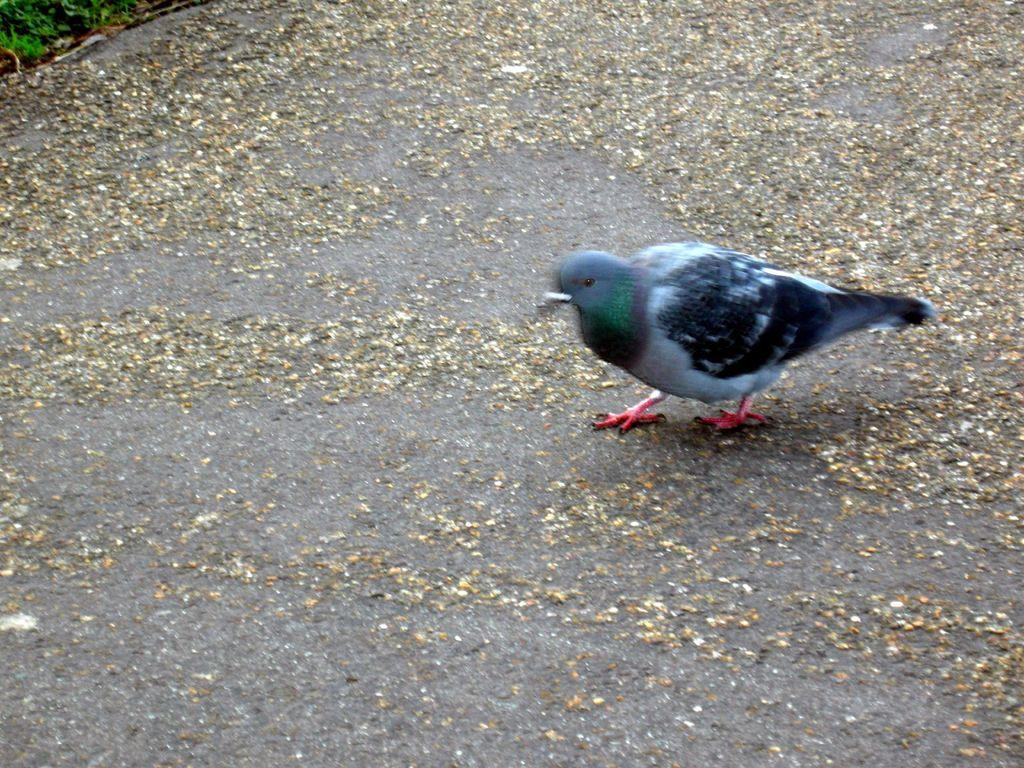What animal can be seen on the ground in the image? There is a pigeon on the ground in the image. What can be seen in the background of the image? There are leaves visible in the background of the image. How many cats are sitting on the slope in the image? There are no cats or slopes present in the image; it features a pigeon on the ground and leaves in the background. 